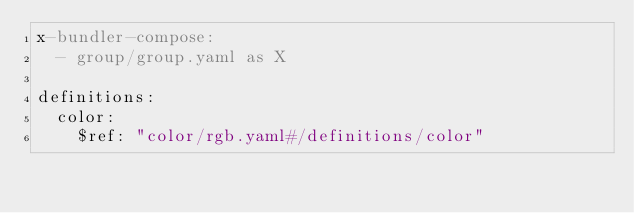<code> <loc_0><loc_0><loc_500><loc_500><_YAML_>x-bundler-compose:
  - group/group.yaml as X

definitions:
  color:
    $ref: "color/rgb.yaml#/definitions/color"
</code> 